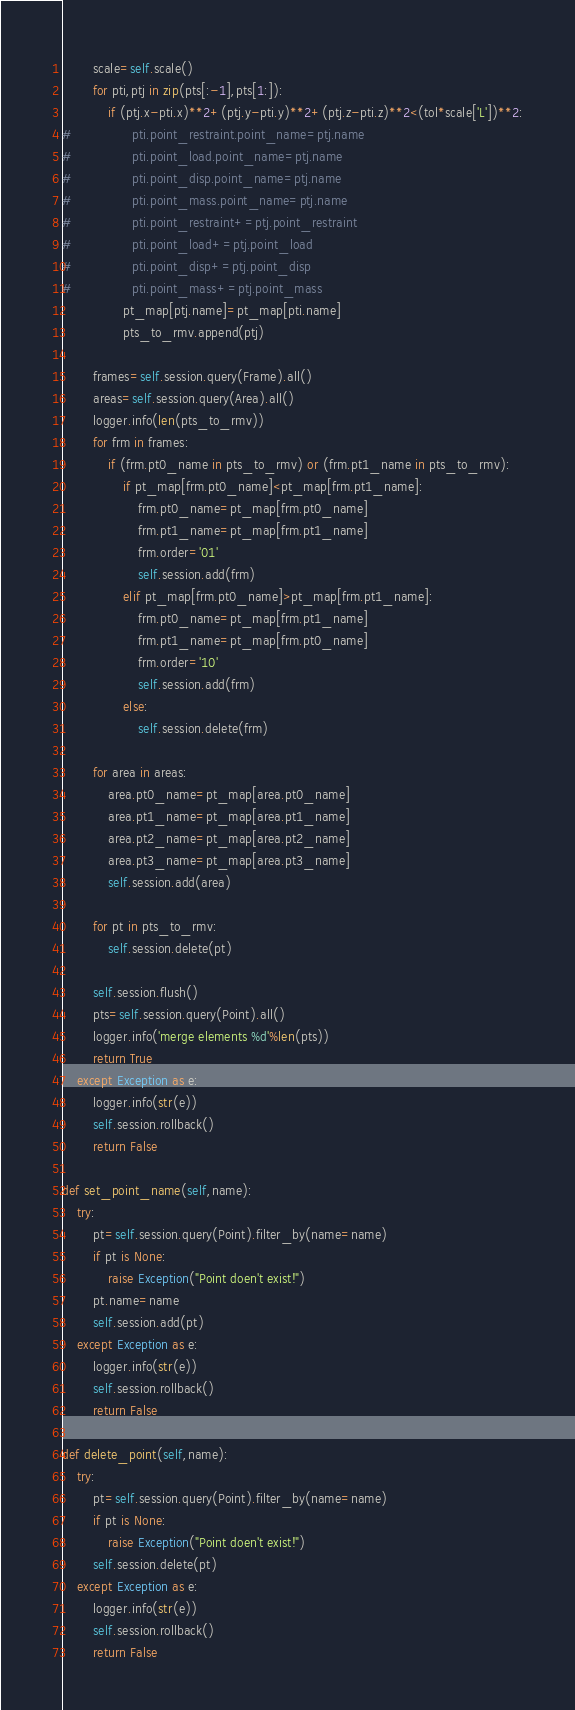Convert code to text. <code><loc_0><loc_0><loc_500><loc_500><_Python_>        scale=self.scale()
        for pti,ptj in zip(pts[:-1],pts[1:]):
            if (ptj.x-pti.x)**2+(ptj.y-pti.y)**2+(ptj.z-pti.z)**2<(tol*scale['L'])**2:
#                pti.point_restraint.point_name=ptj.name
#                pti.point_load.point_name=ptj.name
#                pti.point_disp.point_name=ptj.name
#                pti.point_mass.point_name=ptj.name
#                pti.point_restraint+=ptj.point_restraint
#                pti.point_load+=ptj.point_load
#                pti.point_disp+=ptj.point_disp
#                pti.point_mass+=ptj.point_mass
                pt_map[ptj.name]=pt_map[pti.name]
                pts_to_rmv.append(ptj)
                
        frames=self.session.query(Frame).all()
        areas=self.session.query(Area).all()
        logger.info(len(pts_to_rmv))
        for frm in frames:
            if (frm.pt0_name in pts_to_rmv) or (frm.pt1_name in pts_to_rmv):
                if pt_map[frm.pt0_name]<pt_map[frm.pt1_name]:
                    frm.pt0_name=pt_map[frm.pt0_name]
                    frm.pt1_name=pt_map[frm.pt1_name]
                    frm.order='01'
                    self.session.add(frm)
                elif pt_map[frm.pt0_name]>pt_map[frm.pt1_name]:
                    frm.pt0_name=pt_map[frm.pt1_name]
                    frm.pt1_name=pt_map[frm.pt0_name]
                    frm.order='10'  
                    self.session.add(frm)
                else:
                    self.session.delete(frm)
                
        for area in areas:
            area.pt0_name=pt_map[area.pt0_name]
            area.pt1_name=pt_map[area.pt1_name]
            area.pt2_name=pt_map[area.pt2_name]
            area.pt3_name=pt_map[area.pt3_name]
            self.session.add(area)       

        for pt in pts_to_rmv:
            self.session.delete(pt) 
                
        self.session.flush()
        pts=self.session.query(Point).all()
        logger.info('merge elements %d'%len(pts))
        return True
    except Exception as e:
        logger.info(str(e))
        self.session.rollback()
        return False
    
def set_point_name(self,name):
    try:
        pt=self.session.query(Point).filter_by(name=name)
        if pt is None:
            raise Exception("Point doen't exist!")
        pt.name=name
        self.session.add(pt)
    except Exception as e:
        logger.info(str(e))
        self.session.rollback()
        return False
    
def delete_point(self,name):
    try:
        pt=self.session.query(Point).filter_by(name=name)
        if pt is None:
            raise Exception("Point doen't exist!")
        self.session.delete(pt)
    except Exception as e:
        logger.info(str(e))
        self.session.rollback()
        return False</code> 